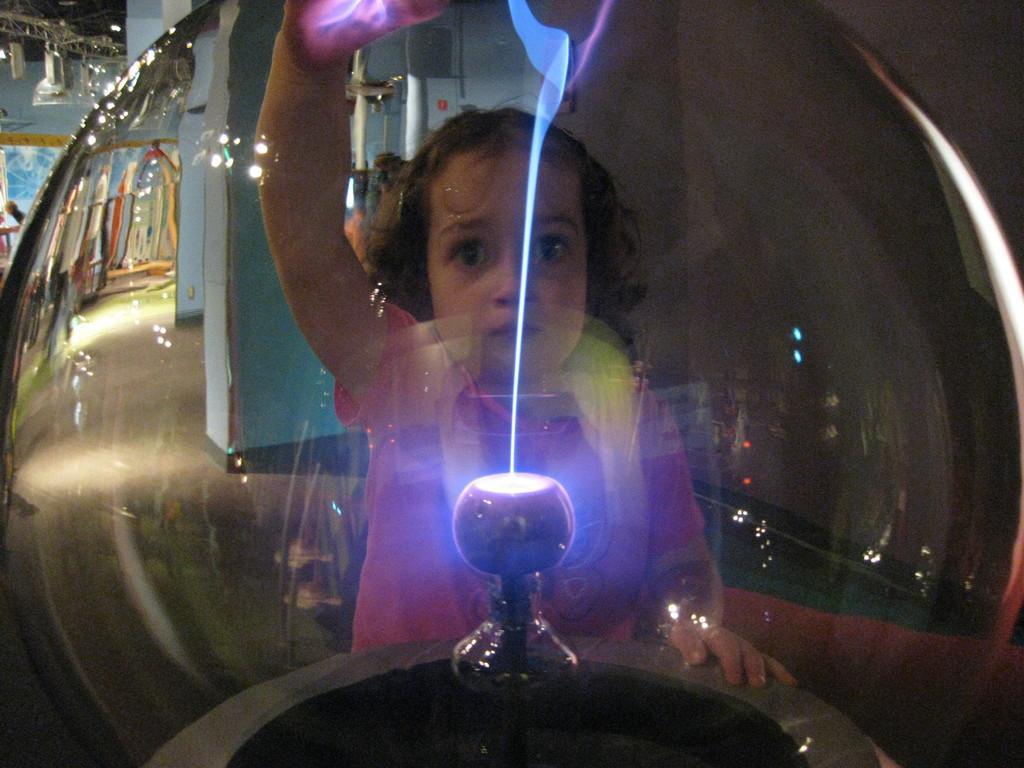Please provide a concise description of this image. In the middle of this image, there is a girl, holding an object placing a hand on a transparent sphere. In this sphere, we can see there is a light on a platform. In the background, there are lights attached to the roof and there are other objects. 